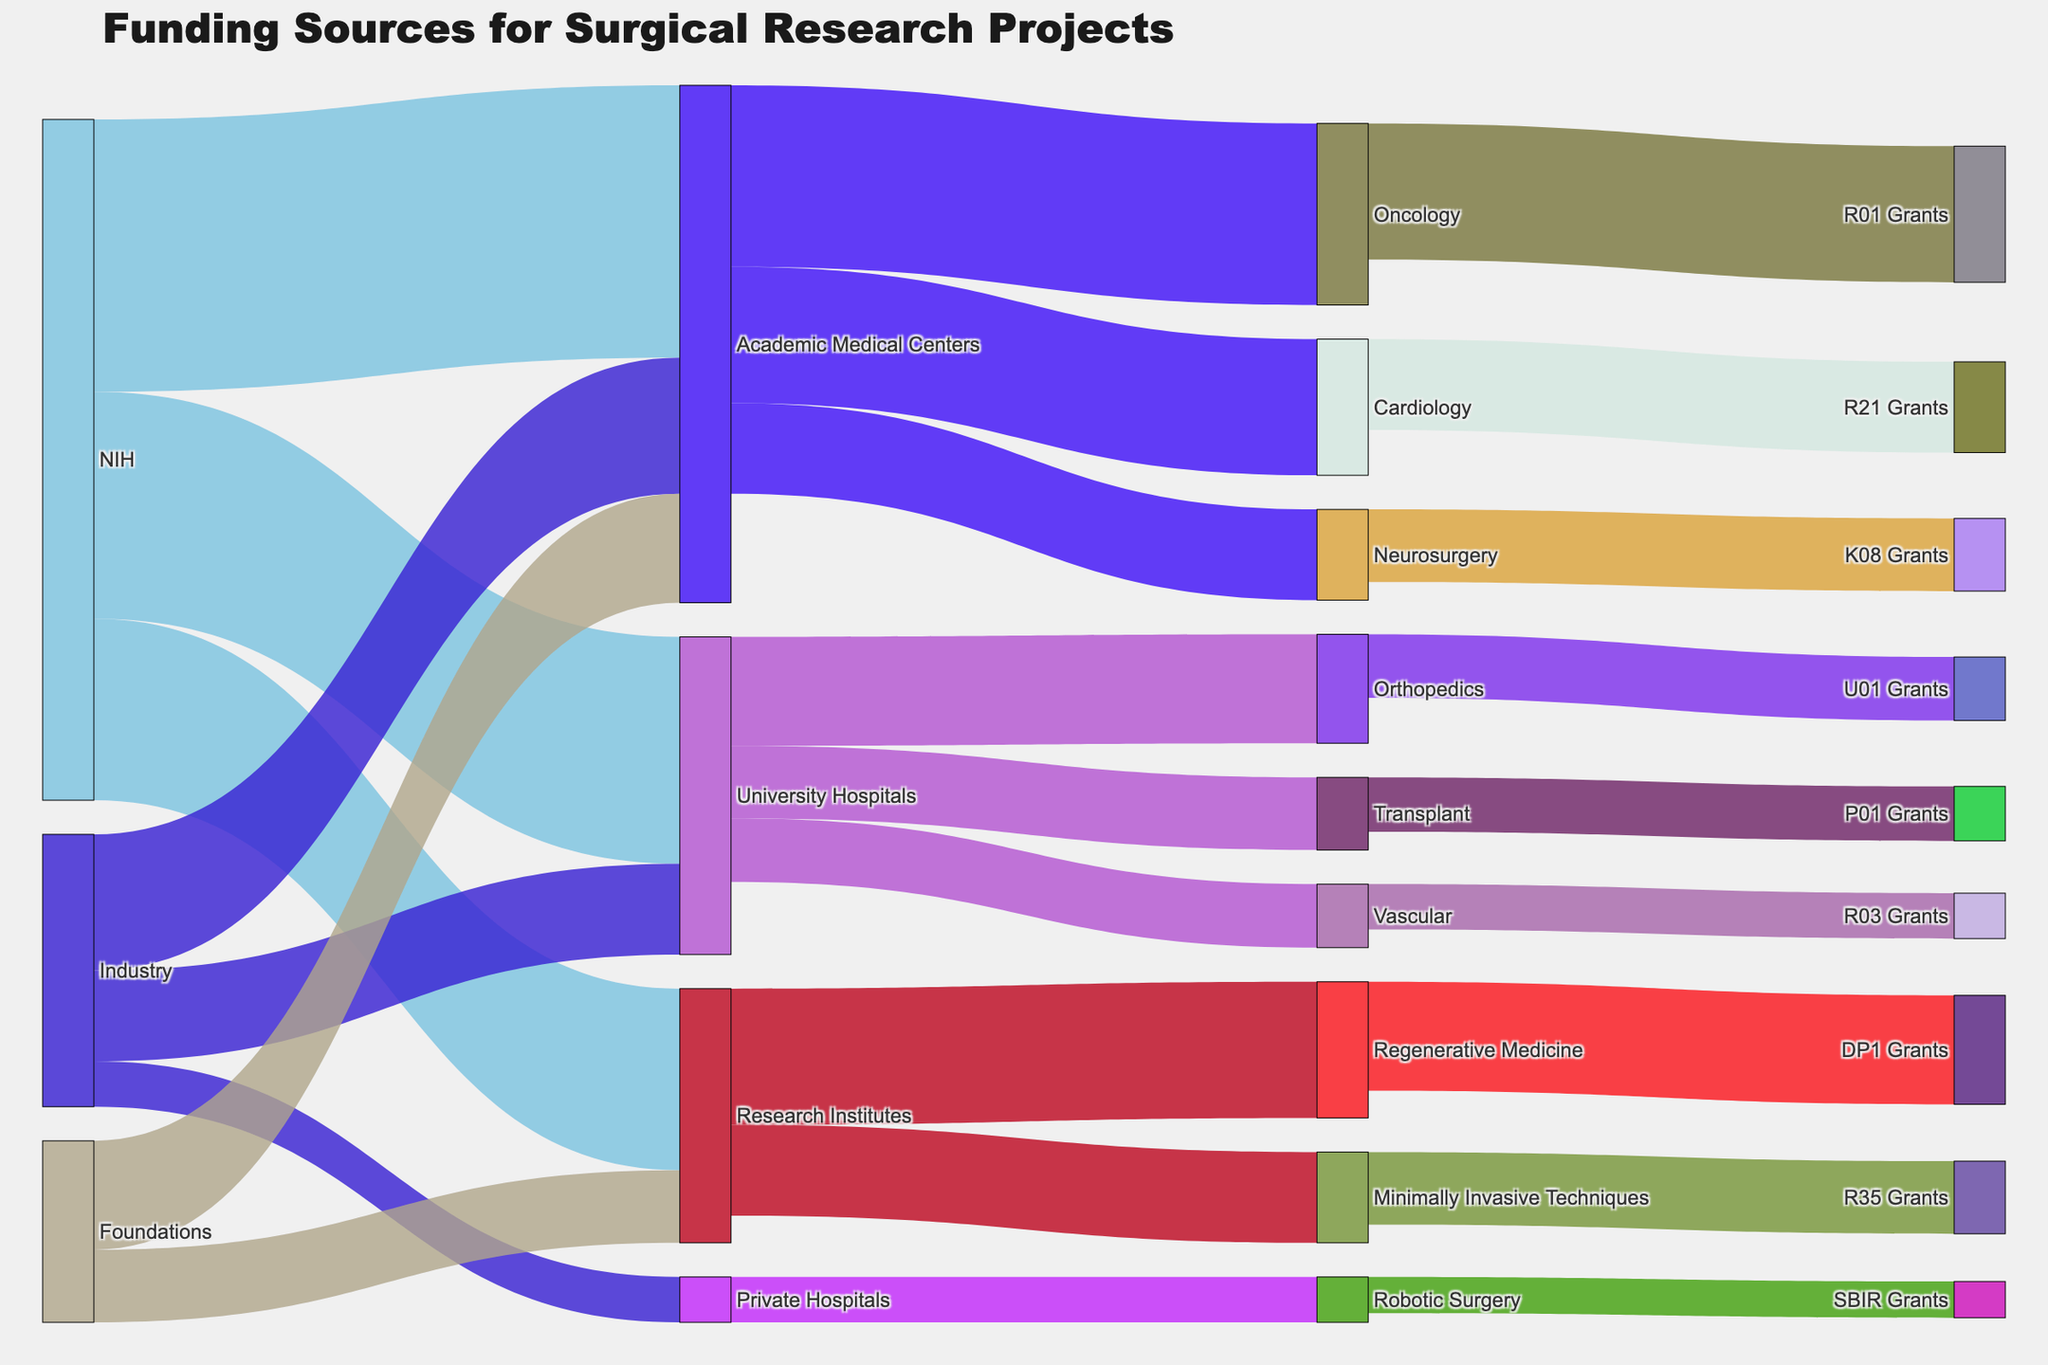What is the primary funding source for Academic Medical Centers? To identify the primary funding source for Academic Medical Centers, observe the flows from the sources to Academic Medical Centers. NIH provides the most funding with a value of 30.
Answer: NIH Which institution type received funding from Industry but does not focus on oncology? Industry funds Academic Medical Centers, University Hospitals, and Private Hospitals. Among these, only Academic Medical Centers focus on oncology, leaving University Hospitals and Private Hospitals.
Answer: University Hospitals and Private Hospitals How much funding do University Hospitals receive in total? Sum the values of all funding sources directed to University Hospitals. NIH contributes 25, and Industry contributes 10. So, the total funding is 25 + 10 = 35.
Answer: 35 Which research focus area receives the most funding from NIH? To determine which area receives the most NIH funding, trace the flows from NIH to different institution types and then from those institutions to research focus areas. Academic Medical Centers funded by NIH directs 20 to Oncology, the highest among all focus areas.
Answer: Oncology What is the total value of funding directed towards Oncology? Add the funding from Academic Medical Centers (20), which is funded by NIH to Oncology and the funding from any other sources if applicable. Only Academic Medical Centers provide funding to Oncology.
Answer: 20 Compare the funding distribution between Cardiology and Vascular research. Which has more funding? To compare the funding, first identify the flows to Cardiology and Vascular. Academic Medical Centers direct 15 to Cardiology, while University Hospitals direct 7 to Vascular. Cardiology thus receives more.
Answer: Cardiology How does the funding from Foundations to Research Institutes compare to that from Industry to the same institution type? To compare, check the values from the Foundations and Industry directed to Research Institutes. Foundations contribute 8, while Industry provides 0 to Research Institutes.
Answer: Foundations What percentage of NIH funding goes to University Hospitals? First, identify total NIH funding (30 + 25 + 20 = 75). Then, find the NIH funding directed to University Hospitals (25). The calculation is (25/75)*100%.
Answer: 33.33% Which grant category receives the most funding? Trace the flows to grant categories from the research focus areas. R01 Grants from Oncology receives 15, the highest among all categories.
Answer: R01 Grants Among NIH, Industry, and Foundations, which source provides the least funding to any institution type? Check the minimum funding value given by each source to institution types. Industry provides 5 to Private Hospitals, which is the lowest compared to the minimum funding from NIH (20 to Research Institutes) and Foundations (8 to Research Institutes).
Answer: Industry 